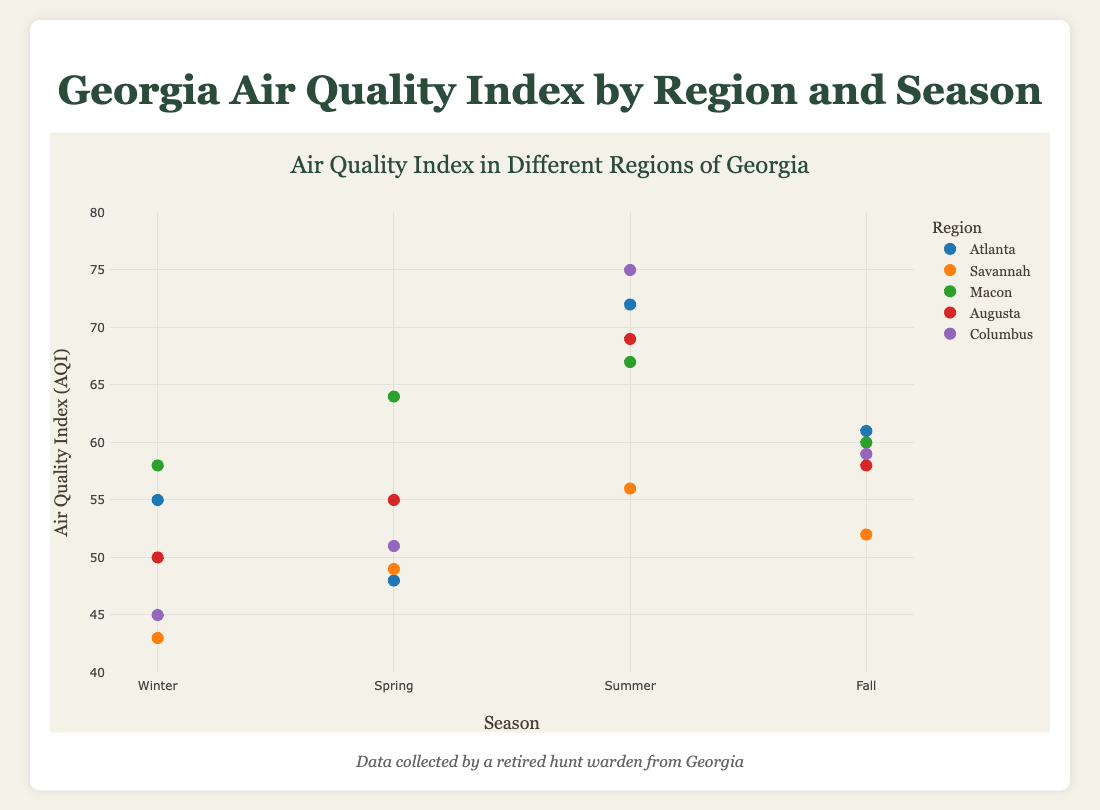what's the title of the figure? The title can be found at the top center of the figure. It usually summarizes the main topic of the plot. In this case, the title is "Georgia Air Quality Index by Region and Season"
Answer: Georgia Air Quality Index by Region and Season what are the regions included in the figure? The regions are indicated in the legend of the figure, next to the colored symbols. The regions shown are Atlanta, Savannah, Macon, Augusta, and Columbus
Answer: Atlanta, Savannah, Macon, Augusta, Columbus which region has the highest AQI value in Summer? Look at the data points for each region during the Summer season, which can be identified on the x-axis under "Summer". The highest AQI value in Summer is for Columbus with an AQI of 75
Answer: Columbus what is the average AQI in Macon across all seasons? Calculate the average AQI in Macon by adding up the AQI values for all four seasons and dividing by four. The AQI values for Macon are 58 (Winter), 64 (Spring), 67 (Summer), and 60 (Fall). The average is (58 + 64 + 67 + 60) / 4 = 62.25
Answer: 62.25 which season generally has the highest AQI values across all regions? Identify the season with the overall highest AQI values by comparing the data points across all regions for each season. Summer shows generally higher AQI values across the regions
Answer: Summer is Savannah's AQI higher in Spring or Fall? Compare Savannah's AQI values in Spring and Fall, which are 49 and 52 respectively. Fall has a higher AQI than Spring in Savannah
Answer: Fall what's the difference in AQI between Winter and Summer in Augusta? To find the difference, subtract the Winter AQI from the Summer AQI in Augusta. The AQI values are 50 (Winter) and 69 (Summer). The difference is 69 - 50 = 19
Answer: 19 which region shows the most variation in AQI across different seasons? Look at the range of AQI values within each region over the seasons. Columbus has the most variation with AQI values ranging from 45 (Winter) to 75 (Summer), giving a total variation of 30
Answer: Columbus what is the AQI value for Atlanta in Spring? Find the data point for Atlanta during the Spring season by locating Atlanta on the legend and Spring on the x-axis. The AQI value for Atlanta in Spring is 48
Answer: 48 